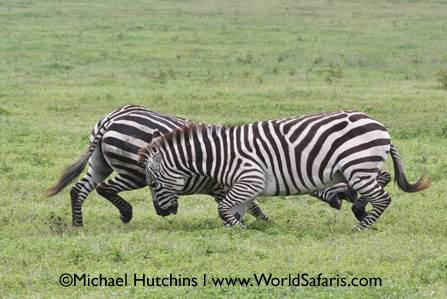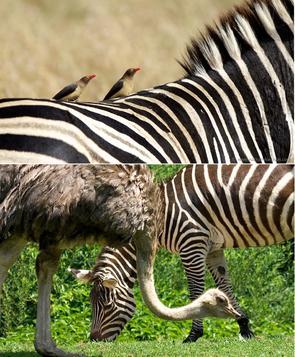The first image is the image on the left, the second image is the image on the right. Evaluate the accuracy of this statement regarding the images: "Fewer than 3 Zebras total.". Is it true? Answer yes or no. No. 